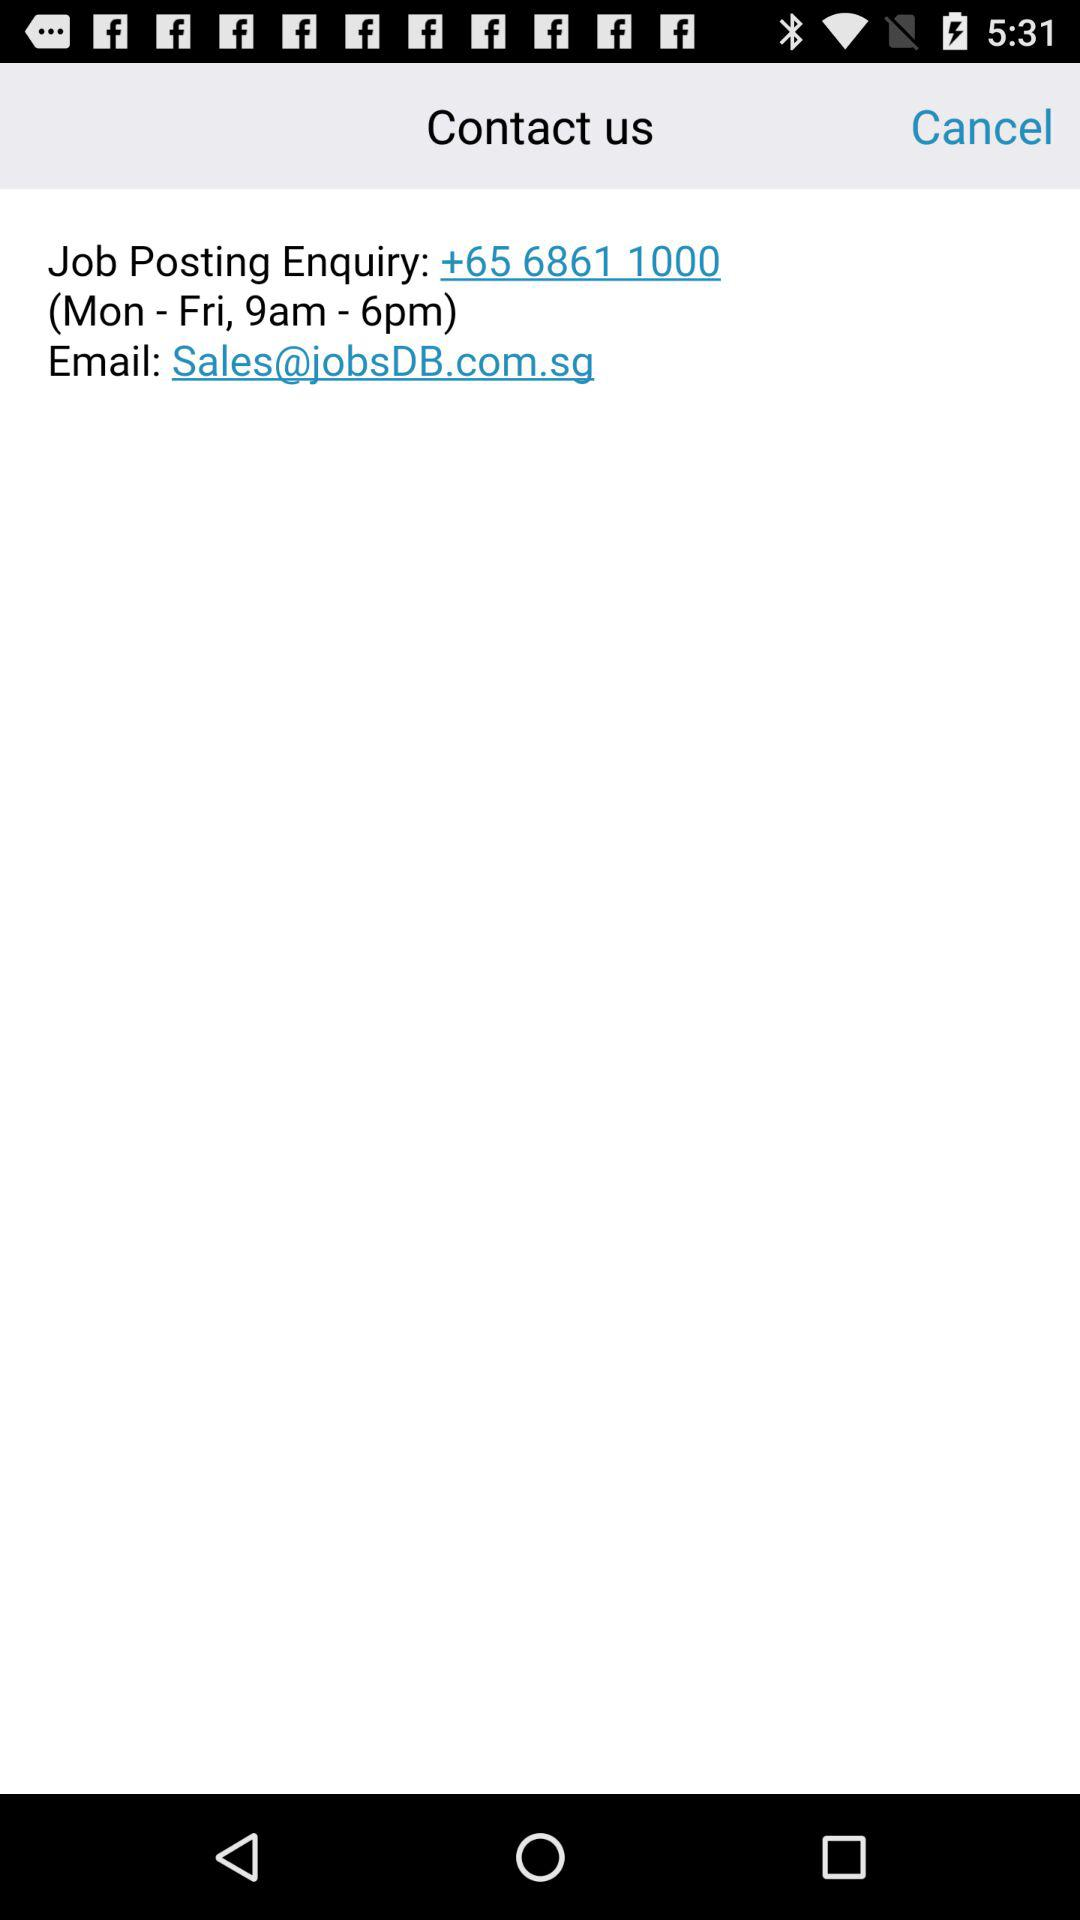What is the contact time? The contact time is Monday to Friday from 9 AM to 6 PM. 